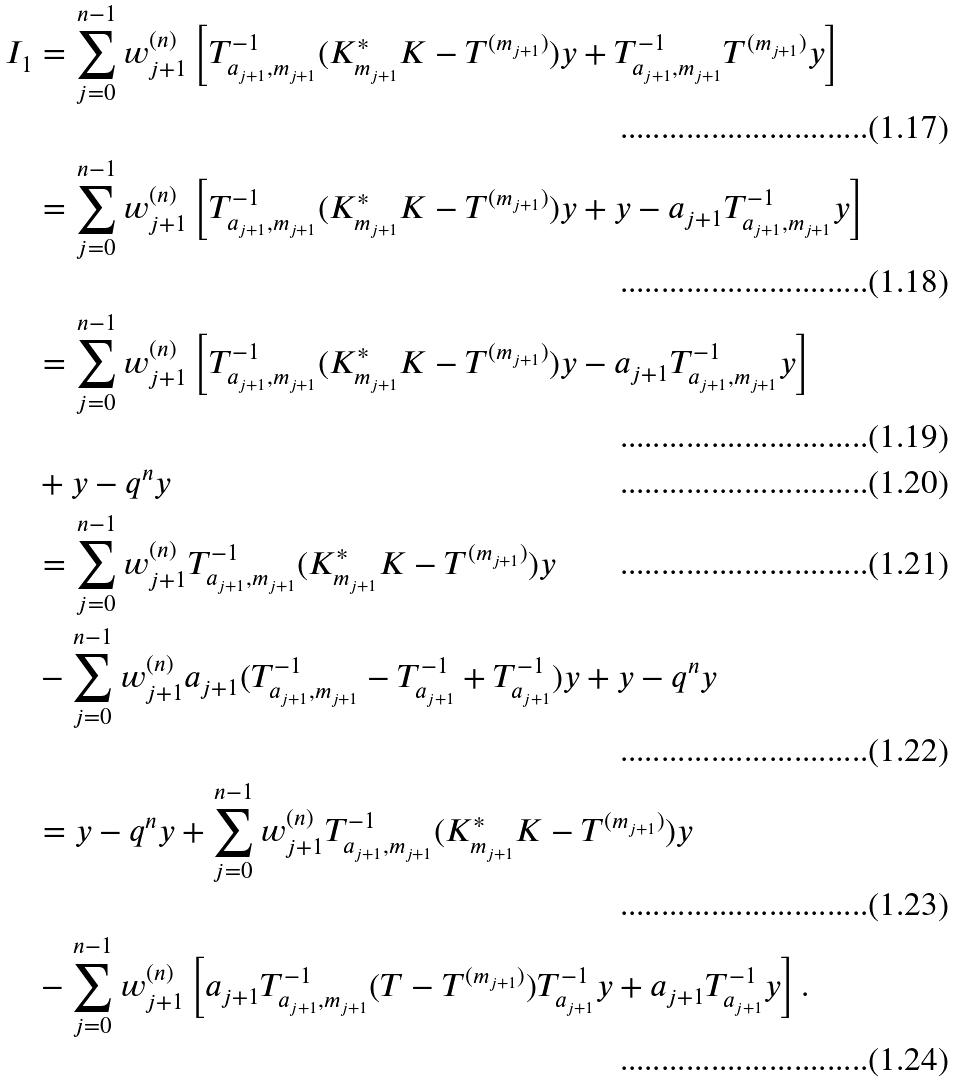<formula> <loc_0><loc_0><loc_500><loc_500>I _ { 1 } & = \sum _ { j = 0 } ^ { n - 1 } w _ { j + 1 } ^ { ( n ) } \left [ T _ { a _ { j + 1 } , m _ { j + 1 } } ^ { - 1 } ( K _ { m _ { j + 1 } } ^ { * } K - T ^ { ( m _ { j + 1 } ) } ) y + T _ { a _ { j + 1 } , m _ { j + 1 } } ^ { - 1 } T ^ { ( m _ { j + 1 } ) } y \right ] \\ & = \sum _ { j = 0 } ^ { n - 1 } w _ { j + 1 } ^ { ( n ) } \left [ T _ { a _ { j + 1 } , m _ { j + 1 } } ^ { - 1 } ( K _ { m _ { j + 1 } } ^ { * } K - T ^ { ( m _ { j + 1 } ) } ) y + y - a _ { j + 1 } T _ { a _ { j + 1 } , m _ { j + 1 } } ^ { - 1 } y \right ] \\ & = \sum _ { j = 0 } ^ { n - 1 } w _ { j + 1 } ^ { ( n ) } \left [ T _ { a _ { j + 1 } , m _ { j + 1 } } ^ { - 1 } ( K _ { m _ { j + 1 } } ^ { * } K - T ^ { ( m _ { j + 1 } ) } ) y - a _ { j + 1 } T _ { a _ { j + 1 } , m _ { j + 1 } } ^ { - 1 } y \right ] \\ & + y - q ^ { n } y \\ & = \sum _ { j = 0 } ^ { n - 1 } w _ { j + 1 } ^ { ( n ) } T _ { a _ { j + 1 } , m _ { j + 1 } } ^ { - 1 } ( K _ { m _ { j + 1 } } ^ { * } K - T ^ { ( m _ { j + 1 } ) } ) y \\ & - \sum _ { j = 0 } ^ { n - 1 } w _ { j + 1 } ^ { ( n ) } a _ { j + 1 } ( T _ { a _ { j + 1 } , m _ { j + 1 } } ^ { - 1 } - T _ { a _ { j + 1 } } ^ { - 1 } + T _ { a _ { j + 1 } } ^ { - 1 } ) y + y - q ^ { n } y \\ & = y - q ^ { n } y + \sum _ { j = 0 } ^ { n - 1 } w _ { j + 1 } ^ { ( n ) } T _ { a _ { j + 1 } , m _ { j + 1 } } ^ { - 1 } ( K _ { m _ { j + 1 } } ^ { * } K - T ^ { ( m _ { j + 1 } ) } ) y \\ & - \sum _ { j = 0 } ^ { n - 1 } w _ { j + 1 } ^ { ( n ) } \left [ a _ { j + 1 } T _ { a _ { j + 1 } , m _ { j + 1 } } ^ { - 1 } ( T - T ^ { ( m _ { j + 1 } ) } ) T _ { a _ { j + 1 } } ^ { - 1 } y + a _ { j + 1 } T _ { a _ { j + 1 } } ^ { - 1 } y \right ] .</formula> 